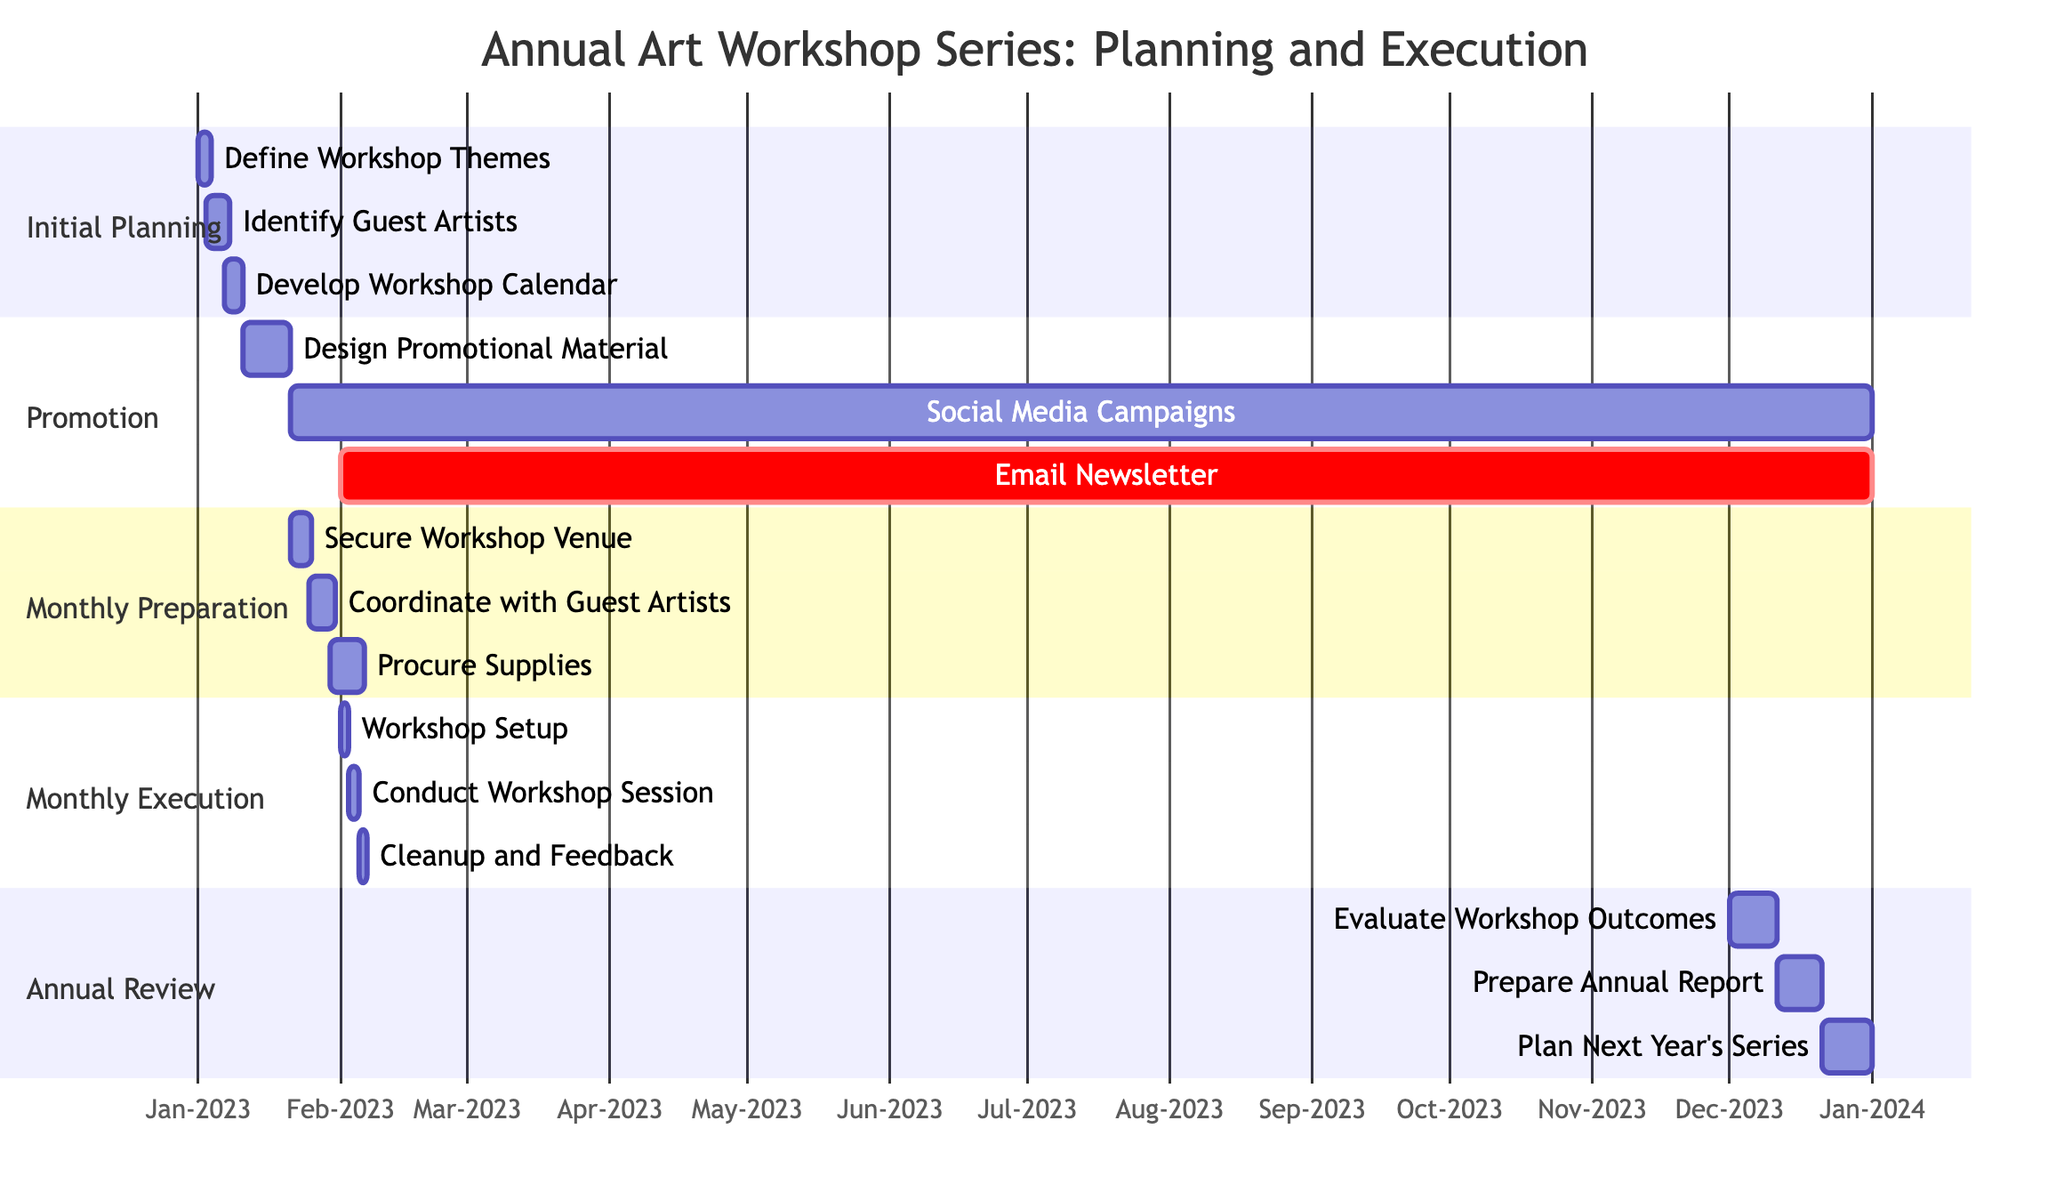What is the duration of the initial workshop planning phase? The initial workshop planning phase starts on January 1, 2023, and ends on January 10, 2023. Calculating the duration, we note that it lasts for 10 days.
Answer: 10 days How many subtasks are involved in the monthly workshop execution? In the monthly workshop execution section, there are three subtasks: Workshop Setup, Conduct Workshop Session, and Cleanup and Feedback Collection. Thus, the total number of subtasks is three.
Answer: 3 Which task overlaps with both preparation and execution phases? The task "Monthly Workshop Preparation" starts on January 21, 2023, and runs until December 31, 2023. The "Monthly Workshop Execution" also starts on February 1, 2023, and ends on December 31, 2023. Hence, it overlaps with both phases.
Answer: Monthly Workshop Preparation What is the last day of the workshop series according to the diagram? The final task, "Plan Next Year's Series," ends on December 31, 2023, which is the last day of the workshop series.
Answer: December 31, 2023 When does the "Email Newsletter" task start? The "Email Newsletter" task is indicated to start on February 1, 2023, and this is noted in the diagram.
Answer: February 1, 2023 How long does the process for evaluating workshop outcomes take? The task "Evaluate Workshop Outcomes" starts on December 1, 2023, and ends on December 10, 2023, thus taking 10 days in total.
Answer: 10 days How many days is "Workshop Setup" scheduled for? The task "Workshop Setup" is scheduled to take place from February 1 to February 2, 2023, which is 2 days.
Answer: 2 days Which subtask of “Monthly Workshop Promotion” runs the longest? The "Social Media Campaigns" subtask starts on January 21, 2023, and continues until December 31, 2023, making it the longest running subtask at 345 days.
Answer: Social Media Campaigns What is the duration of the "Prepare Annual Report" task? The "Prepare Annual Report" task begins on December 11, 2023, and concludes on December 20, 2023. Consequently, it spans 10 days.
Answer: 10 days 